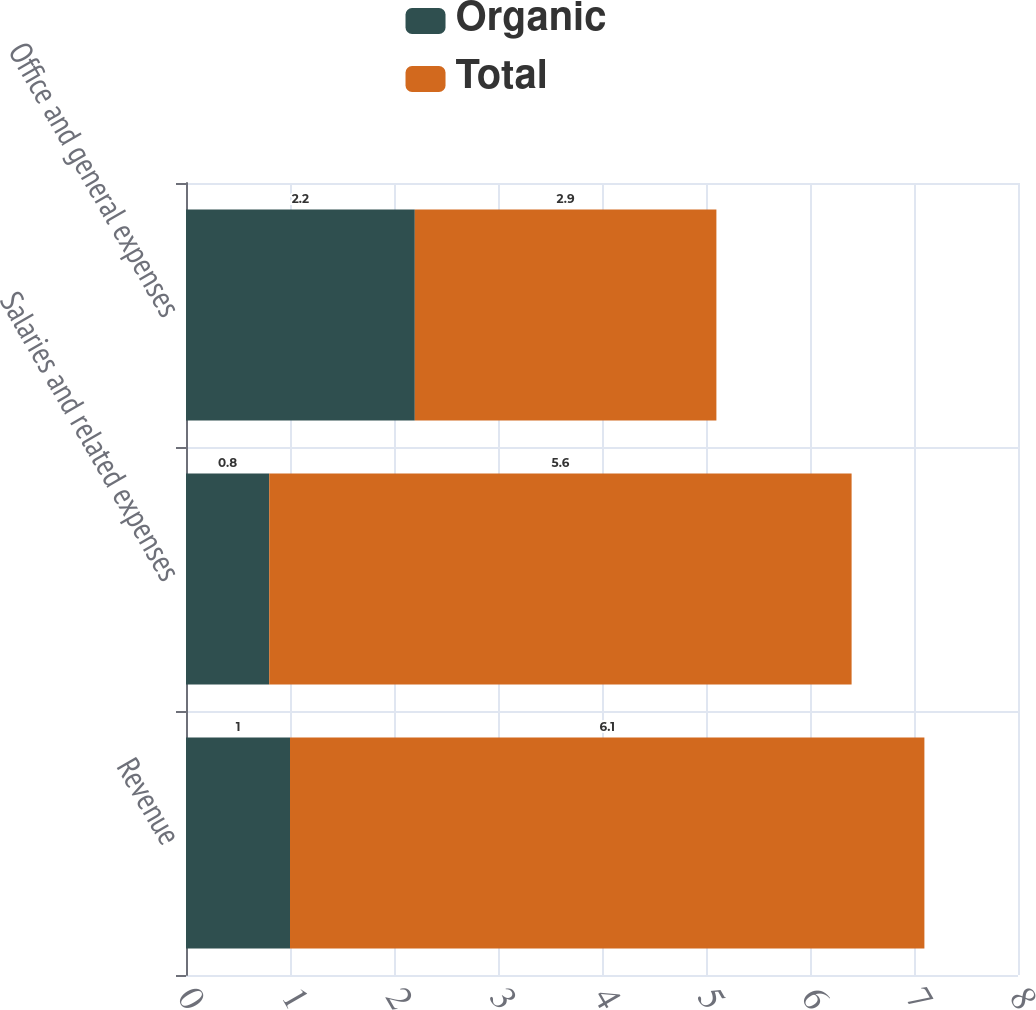Convert chart to OTSL. <chart><loc_0><loc_0><loc_500><loc_500><stacked_bar_chart><ecel><fcel>Revenue<fcel>Salaries and related expenses<fcel>Office and general expenses<nl><fcel>Organic<fcel>1<fcel>0.8<fcel>2.2<nl><fcel>Total<fcel>6.1<fcel>5.6<fcel>2.9<nl></chart> 